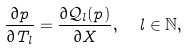Convert formula to latex. <formula><loc_0><loc_0><loc_500><loc_500>\frac { \partial p } { \partial T _ { l } } = \frac { \partial { \mathcal { Q } } _ { l } ( p ) } { \partial X } , \ \ l \in \mathbb { N } ,</formula> 